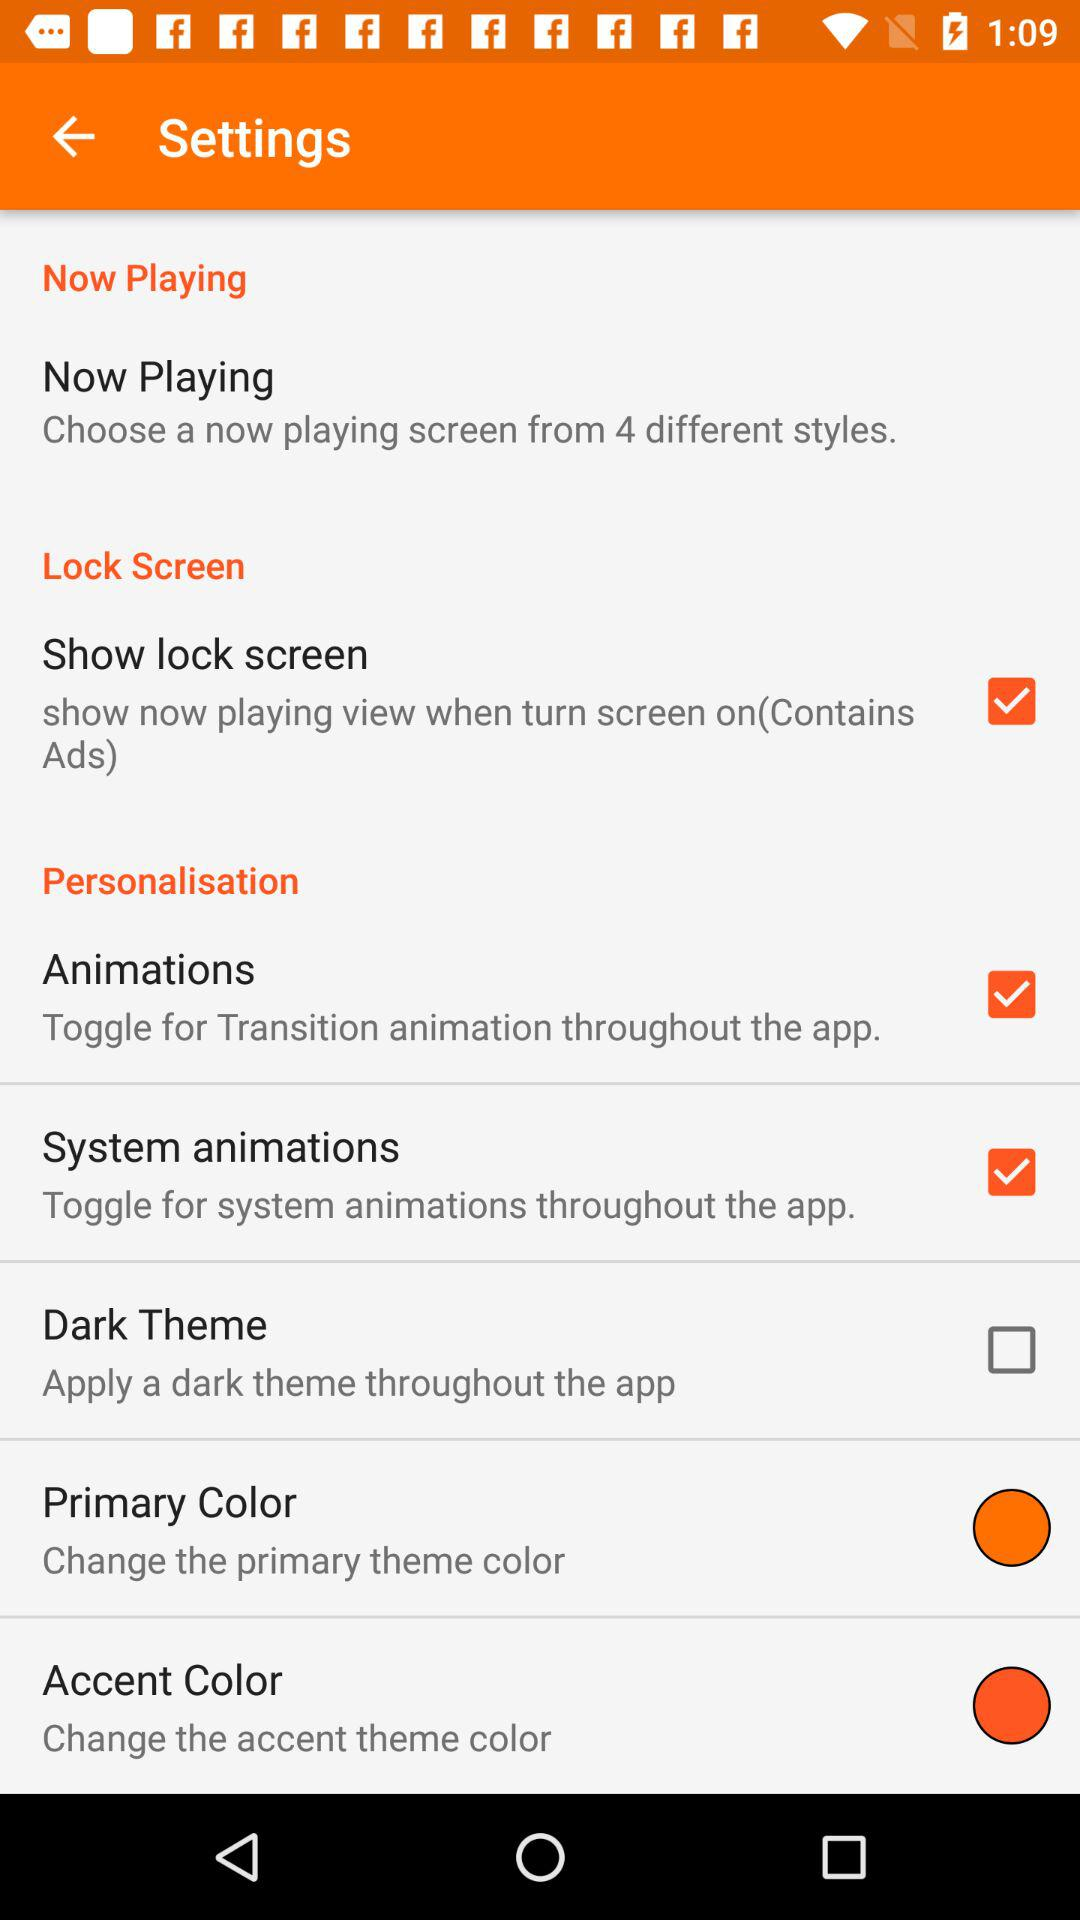What is the status of "System animations"? The status is "on". 